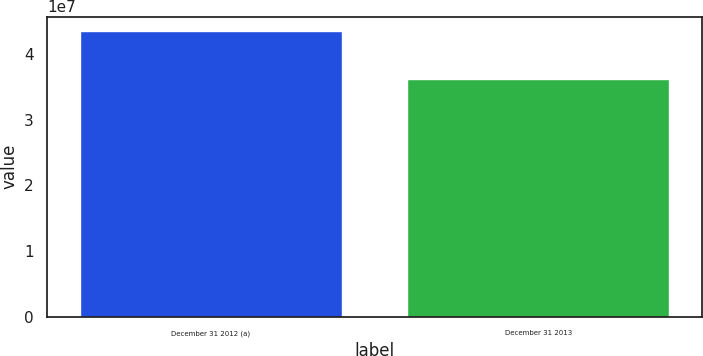<chart> <loc_0><loc_0><loc_500><loc_500><bar_chart><fcel>December 31 2012 (a)<fcel>December 31 2013<nl><fcel>4.35117e+07<fcel>3.6185e+07<nl></chart> 